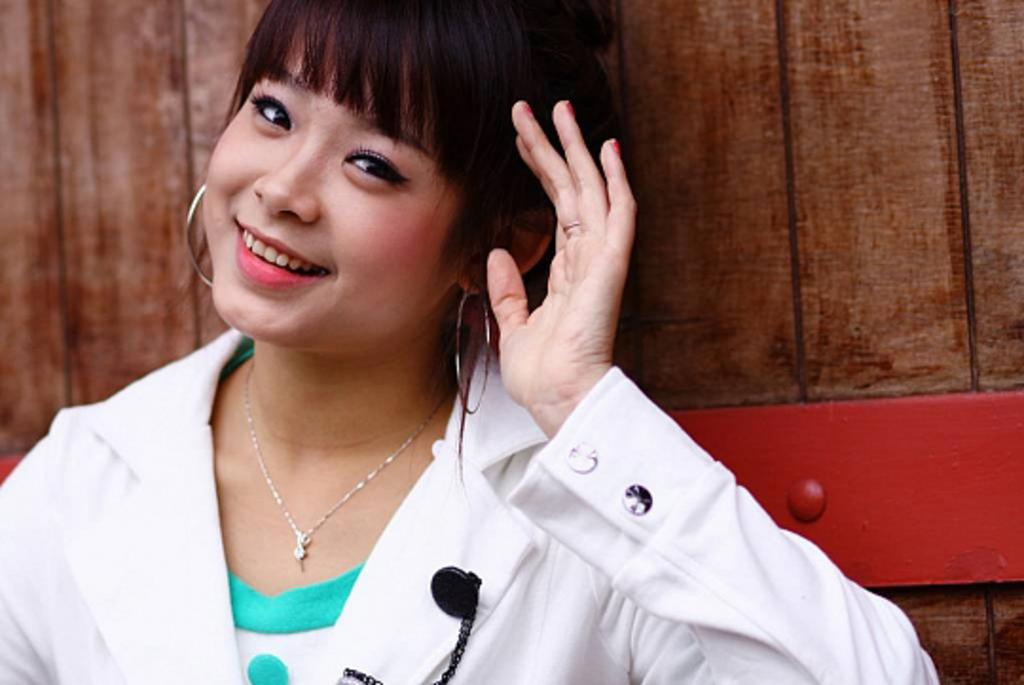What type of object can be seen in the background of the image? There is a wooden object in the background of the image. Who is present in the image? There is a woman in the image. What is the woman doing in the image? The woman is giving a pose. What is the woman's facial expression in the image? The woman is smiling. What is the measurement of the side of the wooden object in the image? There is no specific measurement provided for the wooden object in the image, and therefore it cannot be determined. What type of error is present in the image? There is no error present in the image; it is a clear photograph of a woman posing with a wooden object. 